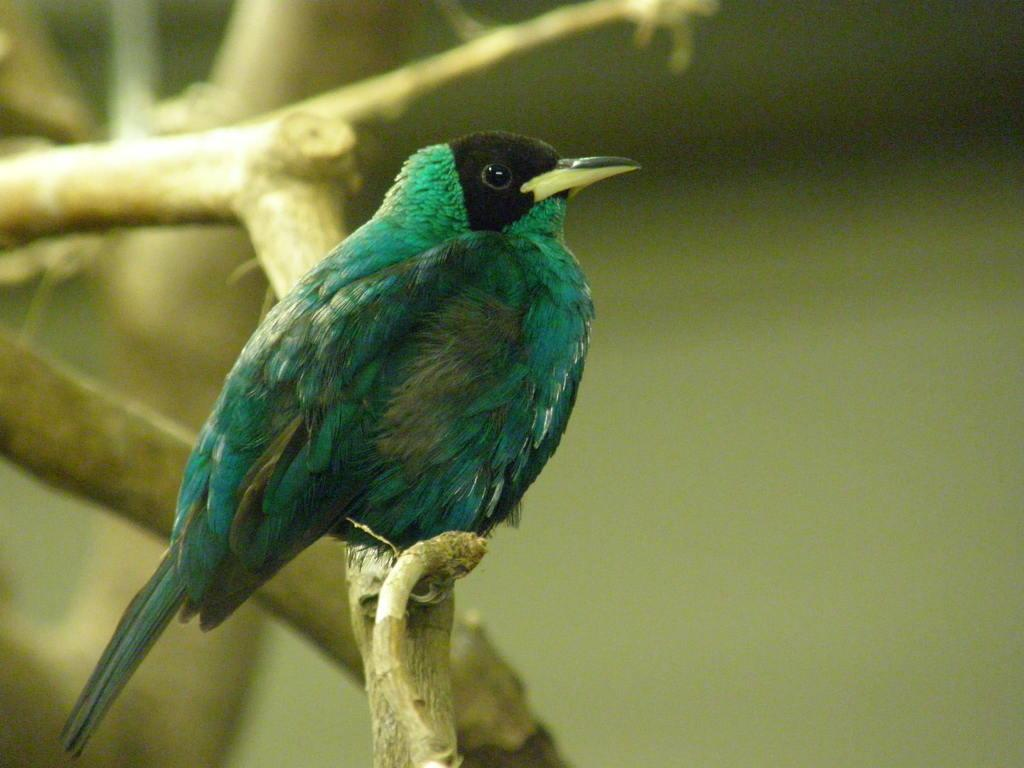What type of animal is in the image? There is a bird in the image. Where is the bird located? The bird is on the branch of a tree. What colors can be seen on the bird? The bird has green and black colors. How would you describe the background of the image? The background of the image is blurred. What type of chair is visible in the image? There is no chair present in the image; it features a bird on a tree branch. What record is being played in the background of the image? There is no record being played in the image; the background is blurred. 